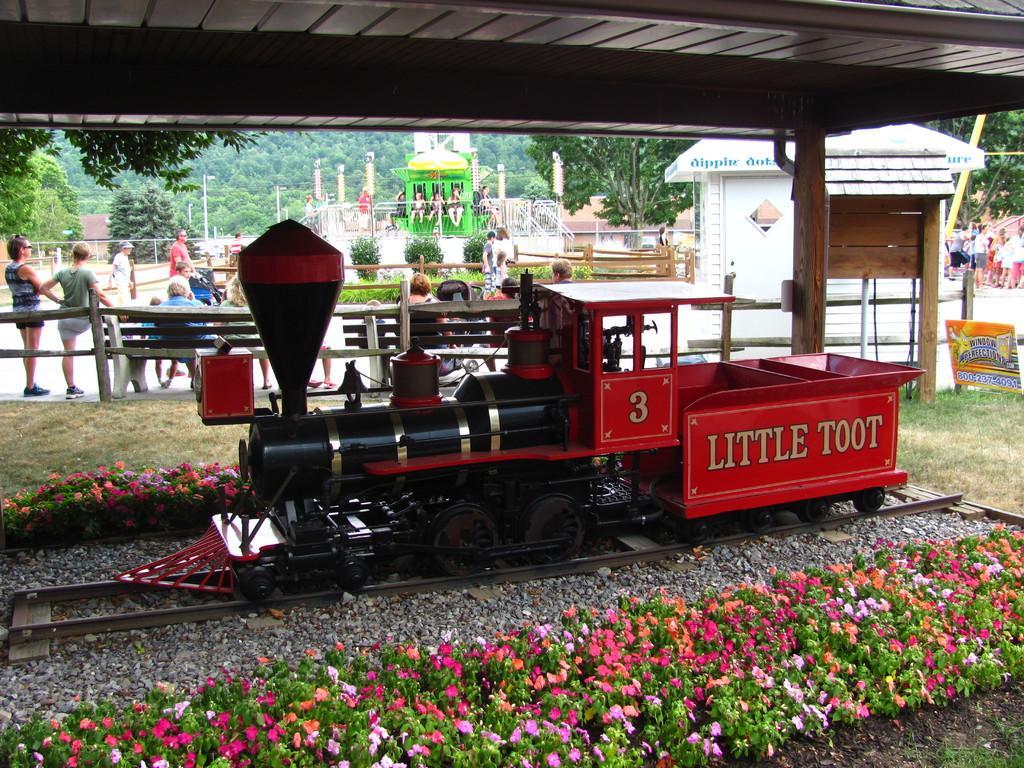Please provide a concise description of this image. There is a train present on a railway track and there are flower plants are present at the bottom of this image. We can see a fence and a group of people in the middle of this image. There are trees and pillars present in the background. 